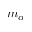<formula> <loc_0><loc_0><loc_500><loc_500>m _ { \alpha }</formula> 